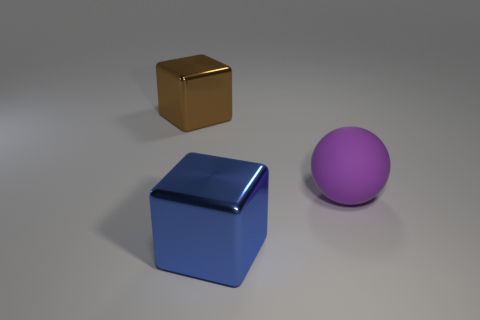There is a big brown object that is the same material as the blue block; what shape is it?
Provide a succinct answer. Cube. There is a large thing on the right side of the block that is in front of the purple thing in front of the brown shiny object; what is it made of?
Offer a very short reply. Rubber. Do the blue metallic block and the metallic thing behind the large blue metallic cube have the same size?
Make the answer very short. Yes. There is a big brown thing that is the same shape as the large blue thing; what is it made of?
Offer a very short reply. Metal. There is a purple object in front of the cube that is behind the big shiny cube right of the brown thing; how big is it?
Provide a succinct answer. Large. Do the rubber thing and the blue metal object have the same size?
Ensure brevity in your answer.  Yes. Is the number of blue shiny cubes the same as the number of purple cylinders?
Provide a succinct answer. No. There is a block that is on the left side of the metallic block that is in front of the big brown object; what is it made of?
Make the answer very short. Metal. Is the shape of the metallic thing in front of the large brown block the same as the large brown shiny object that is behind the blue thing?
Ensure brevity in your answer.  Yes. Are there an equal number of purple spheres that are to the left of the large brown metallic cube and green matte cylinders?
Provide a short and direct response. Yes. 